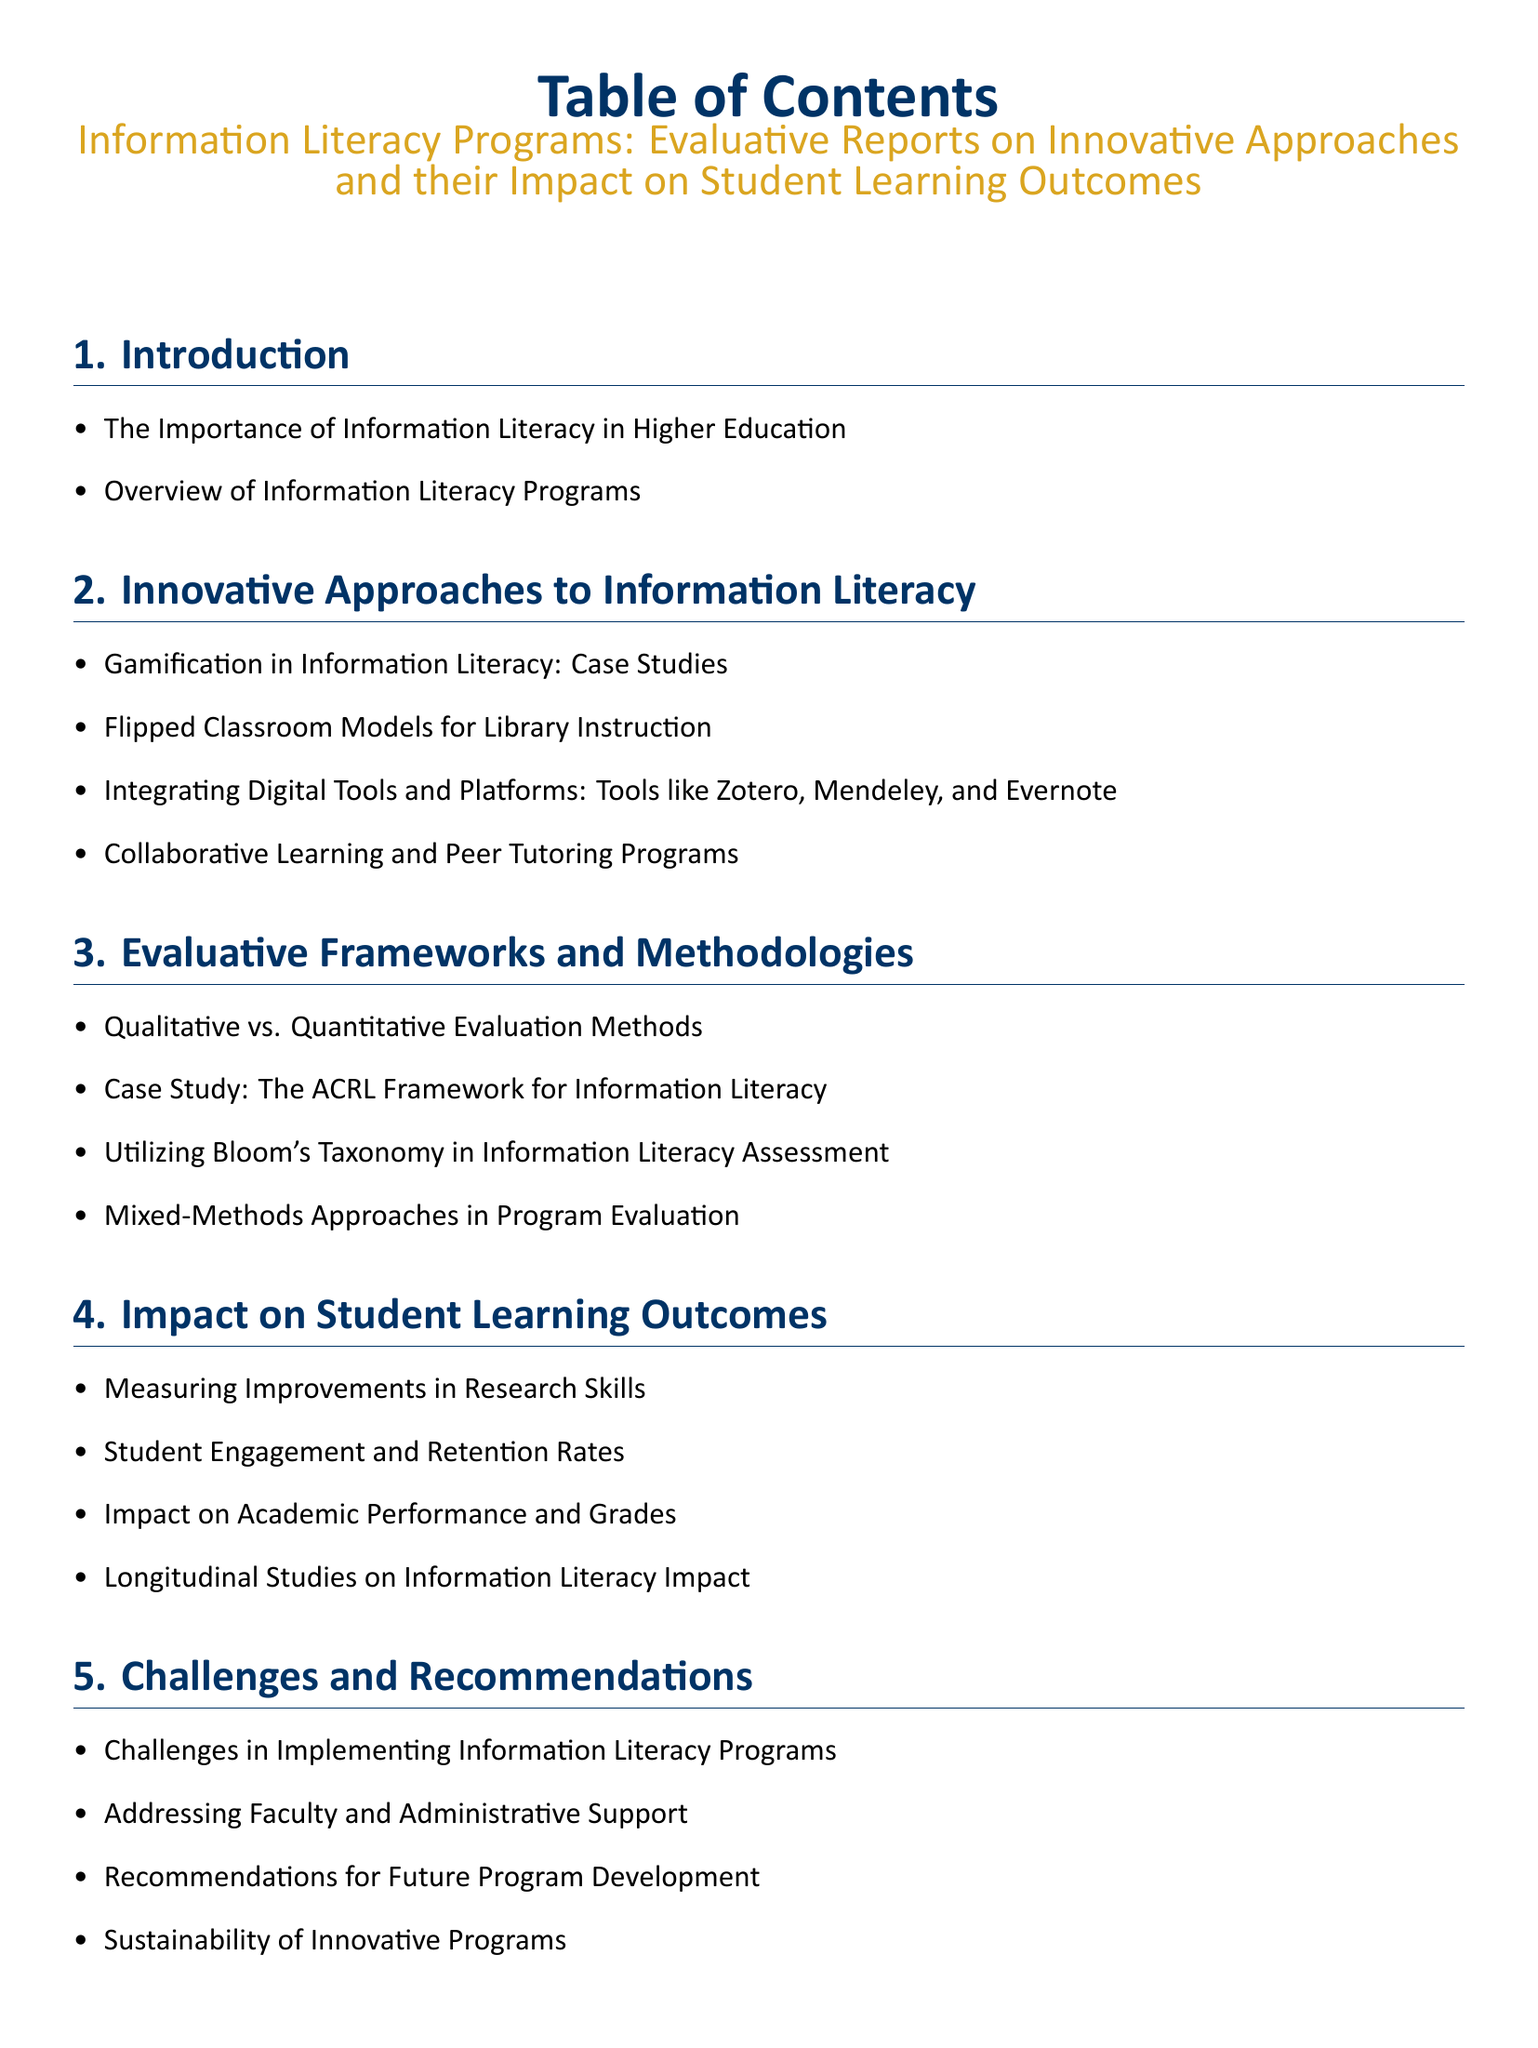What is the title of the document? The title of the document is stated at the top of the Table of Contents section.
Answer: Information Literacy Programs: Evaluative Reports on Innovative Approaches and their Impact on Student Learning Outcomes How many sections are in the document? The sections of the document are listed in the Table of Contents, totaling seven sections.
Answer: 7 What innovative approach is mentioned related to gamification? The document lists "Gamification in Information Literacy: Case Studies" under the Innovative Approaches section.
Answer: Gamification in Information Literacy: Case Studies Which institution's case study focuses on digital literacy workshops? The specific case study is provided in the Case Studies section, identifying the University of California, Berkeley.
Answer: University of California, Berkeley What evaluation method is highlighted in the framework section? The qualitative and quantitative methods mentioned in the Evaluative Frameworks section establish a distinction in evaluation approaches.
Answer: Qualitative vs. Quantitative Evaluation Methods What is one challenge discussed in the recommendations section? The document specifies "Challenges in Implementing Information Literacy Programs" as a challenge in the Challenges and Recommendations section.
Answer: Challenges in Implementing Information Literacy Programs What educational taxonomy is utilized in assessments? The utilization of this framework is indicated in the Evaluative Frameworks section that specifically mentions this educational tool.
Answer: Bloom's Taxonomy What type of studies measure impact on literacy? This term is used to describe comprehensive analysis over time in evaluating educational program impacts as mentioned in the document.
Answer: Longitudinal Studies on Information Literacy Impact 